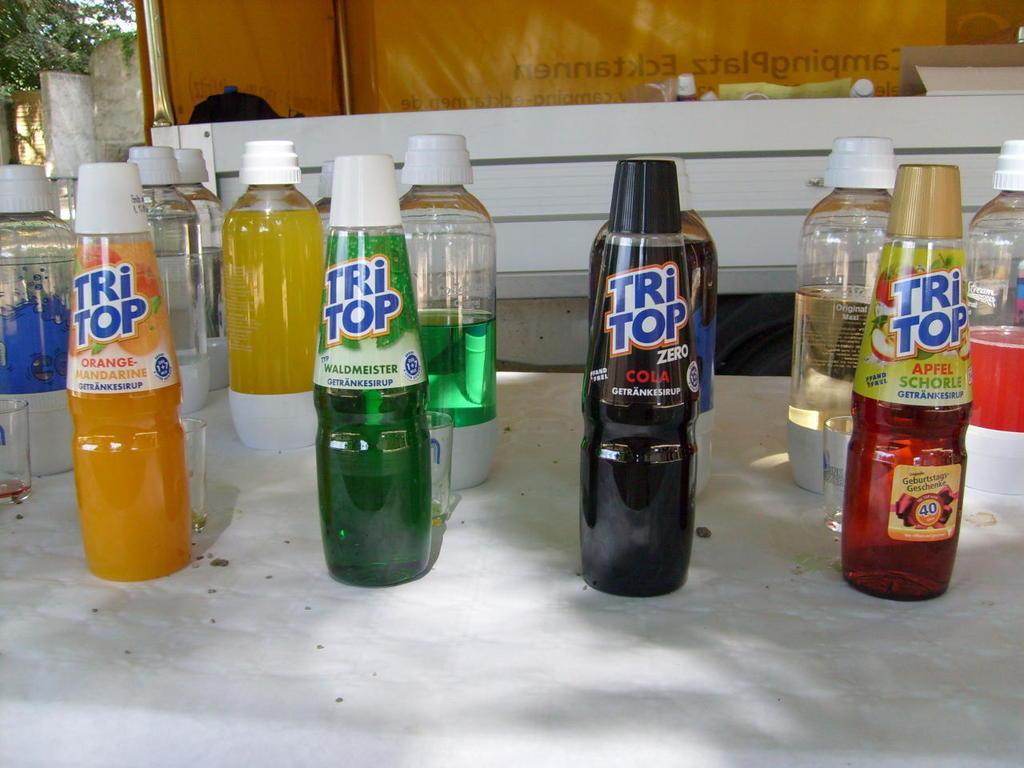Can you describe this image briefly? In this image, we can see so many bottles with lids. That are filled with liquids. That are placed on table. Few glasses we can see. At the background, there is a banner, rod, trees and wall. 